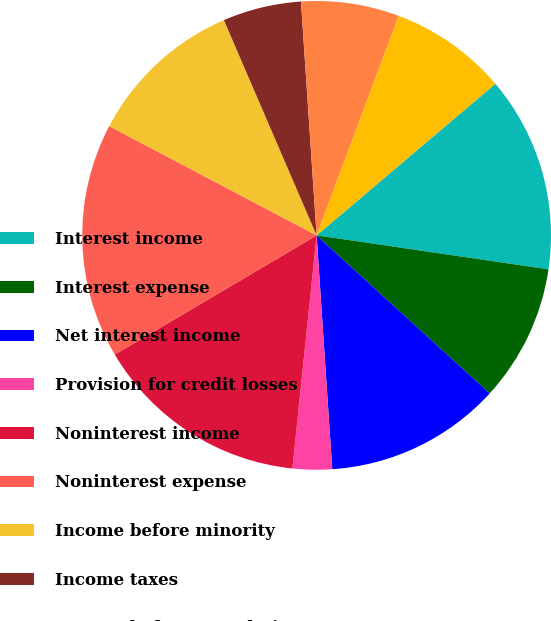Convert chart. <chart><loc_0><loc_0><loc_500><loc_500><pie_chart><fcel>Interest income<fcel>Interest expense<fcel>Net interest income<fcel>Provision for credit losses<fcel>Noninterest income<fcel>Noninterest expense<fcel>Income before minority<fcel>Income taxes<fcel>Income before cumulative<fcel>Net income<nl><fcel>13.51%<fcel>9.46%<fcel>12.16%<fcel>2.71%<fcel>14.86%<fcel>16.21%<fcel>10.81%<fcel>5.41%<fcel>6.76%<fcel>8.11%<nl></chart> 